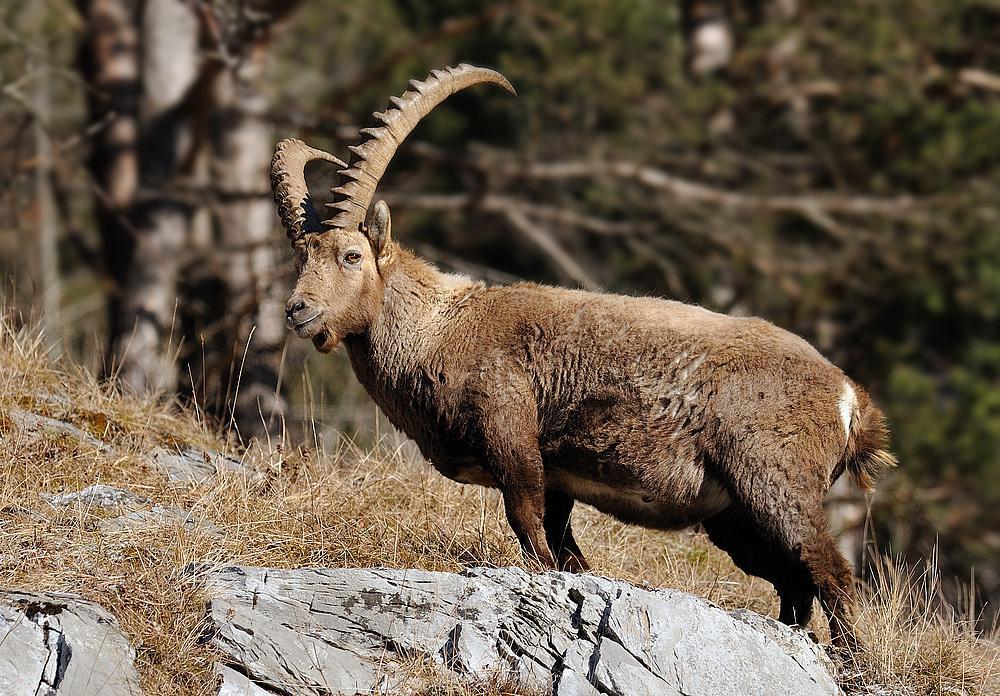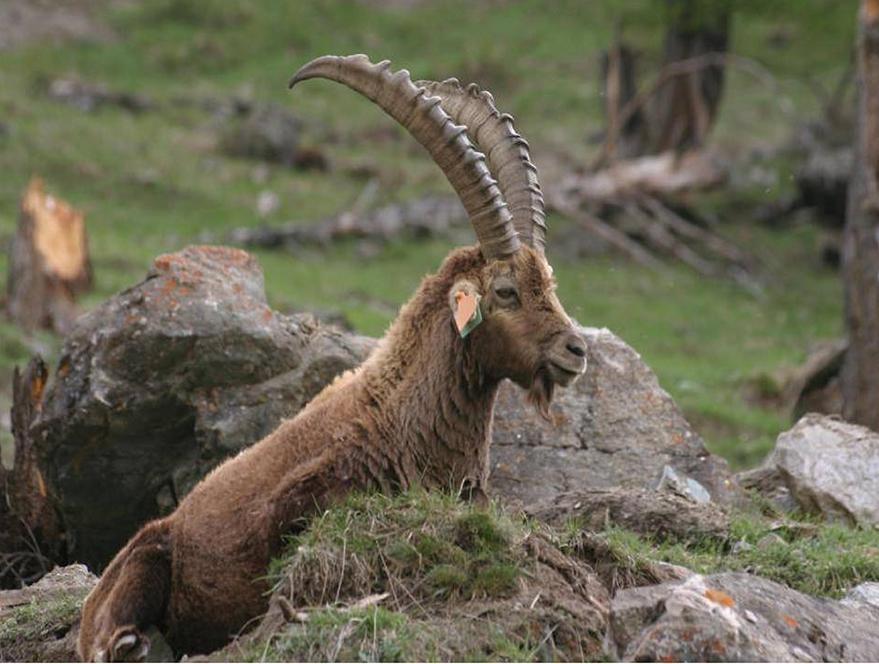The first image is the image on the left, the second image is the image on the right. Given the left and right images, does the statement "One image shows two antelope, which are not butting heads." hold true? Answer yes or no. No. The first image is the image on the left, the second image is the image on the right. Analyze the images presented: Is the assertion "Exactly two horned animals are shown in their native habitat." valid? Answer yes or no. Yes. 